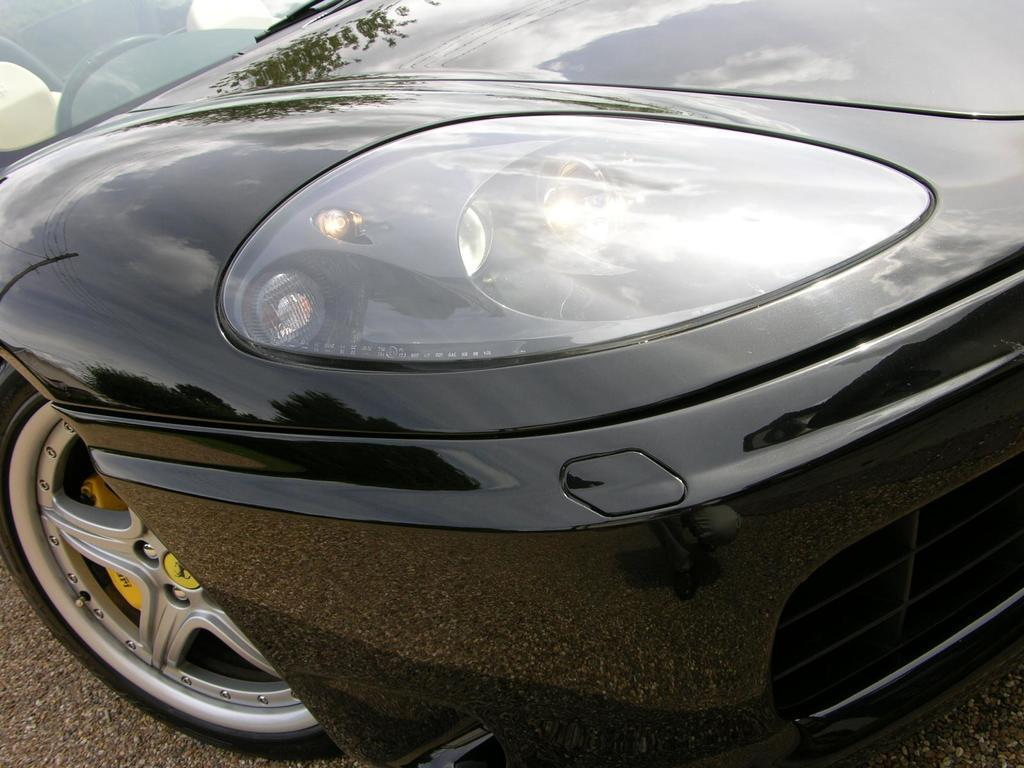Where was the image taken? The image is taken outdoors. What can be seen at the bottom of the image? There is a road at the bottom of the image. What is parked on the road? A car is parked on the road. What is the color of the car? The car is black in color. How many pears are on the car's roof in the image? There are no pears present in the image, and therefore none can be found on the car's roof. 